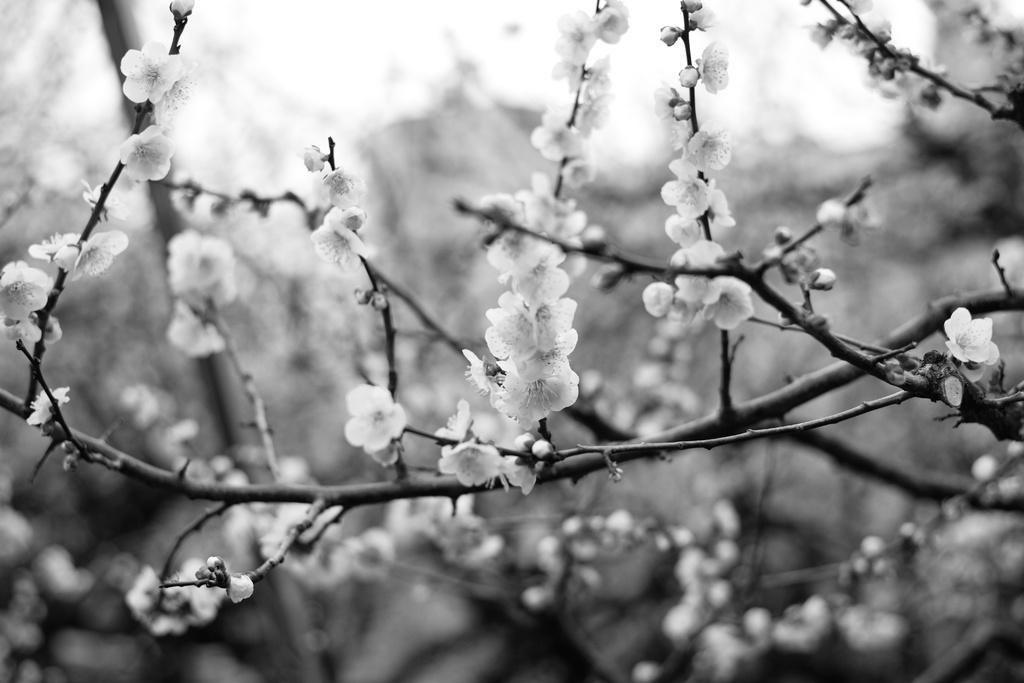What type of plants can be seen in the image? There are flowering plants in the image. What other type of vegetation is present in the image? There are trees in the image. Can you determine the time of day the image was taken? The image was likely taken during the day, as there is sufficient light to see the plants and trees clearly. What type of learning is taking place in the image? There is no indication of any learning activity in the image; it primarily features plants and trees. Is the image set during the winter season? The image does not provide any clues about the season, but the presence of flowering plants suggests it is not winter. 